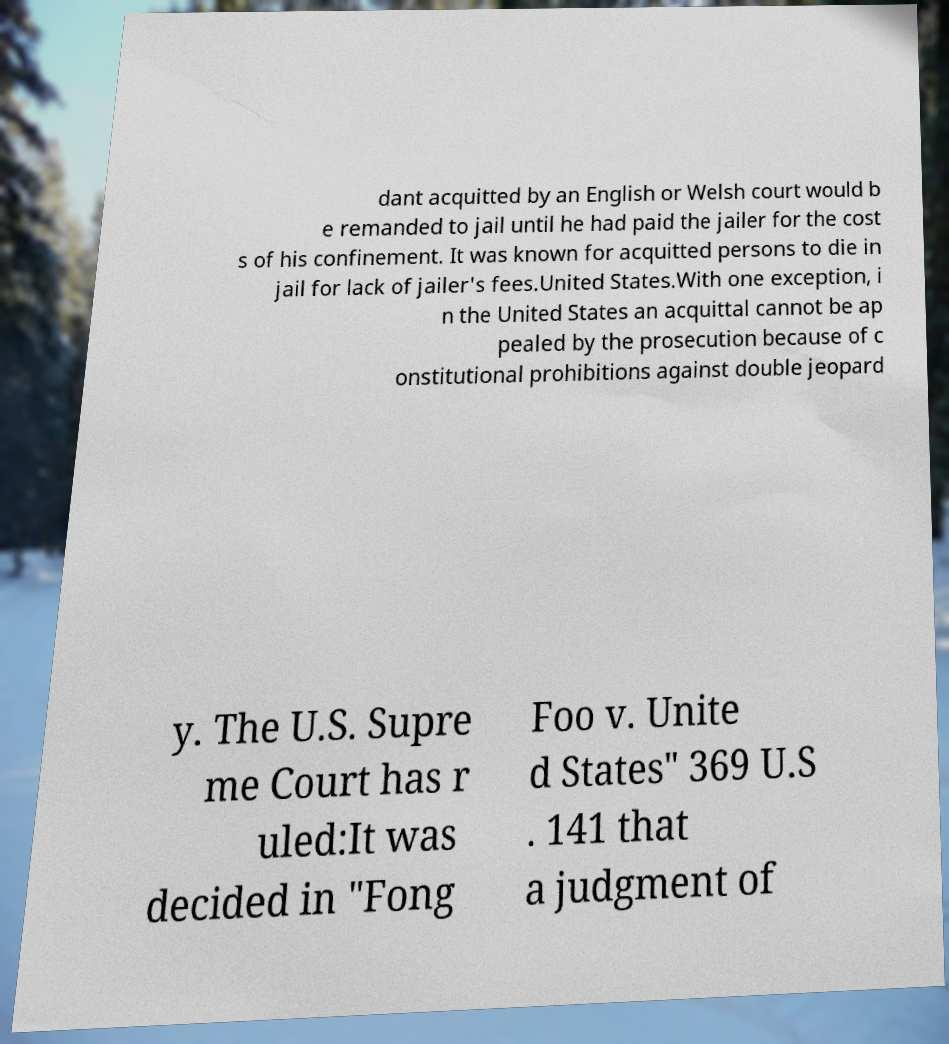Please read and relay the text visible in this image. What does it say? dant acquitted by an English or Welsh court would b e remanded to jail until he had paid the jailer for the cost s of his confinement. It was known for acquitted persons to die in jail for lack of jailer's fees.United States.With one exception, i n the United States an acquittal cannot be ap pealed by the prosecution because of c onstitutional prohibitions against double jeopard y. The U.S. Supre me Court has r uled:It was decided in "Fong Foo v. Unite d States" 369 U.S . 141 that a judgment of 